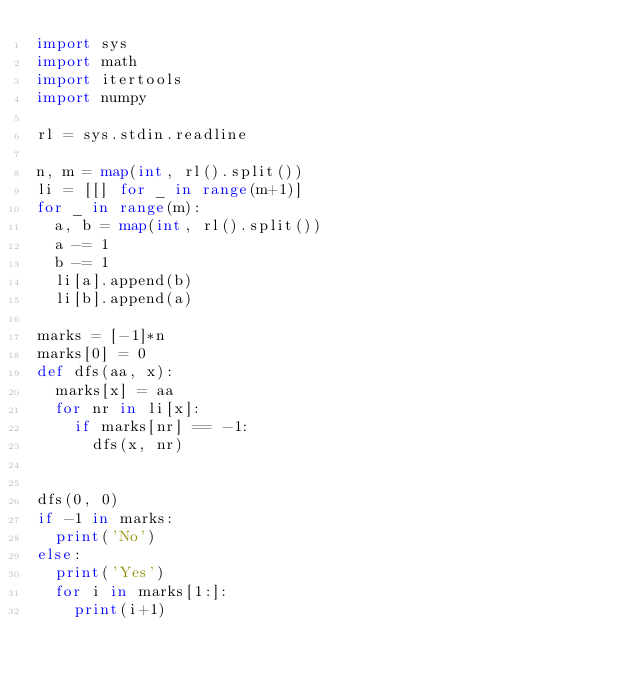<code> <loc_0><loc_0><loc_500><loc_500><_Python_>import sys
import math
import itertools
import numpy

rl = sys.stdin.readline

n, m = map(int, rl().split())
li = [[] for _ in range(m+1)]
for _ in range(m):
  a, b = map(int, rl().split())
  a -= 1
  b -= 1
  li[a].append(b)
  li[b].append(a)

marks = [-1]*n
marks[0] = 0
def dfs(aa, x):
  marks[x] = aa
  for nr in li[x]:
    if marks[nr] == -1:
      dfs(x, nr)
  
  
dfs(0, 0)
if -1 in marks:
  print('No')
else:
  print('Yes')
  for i in marks[1:]:
    print(i+1)
</code> 